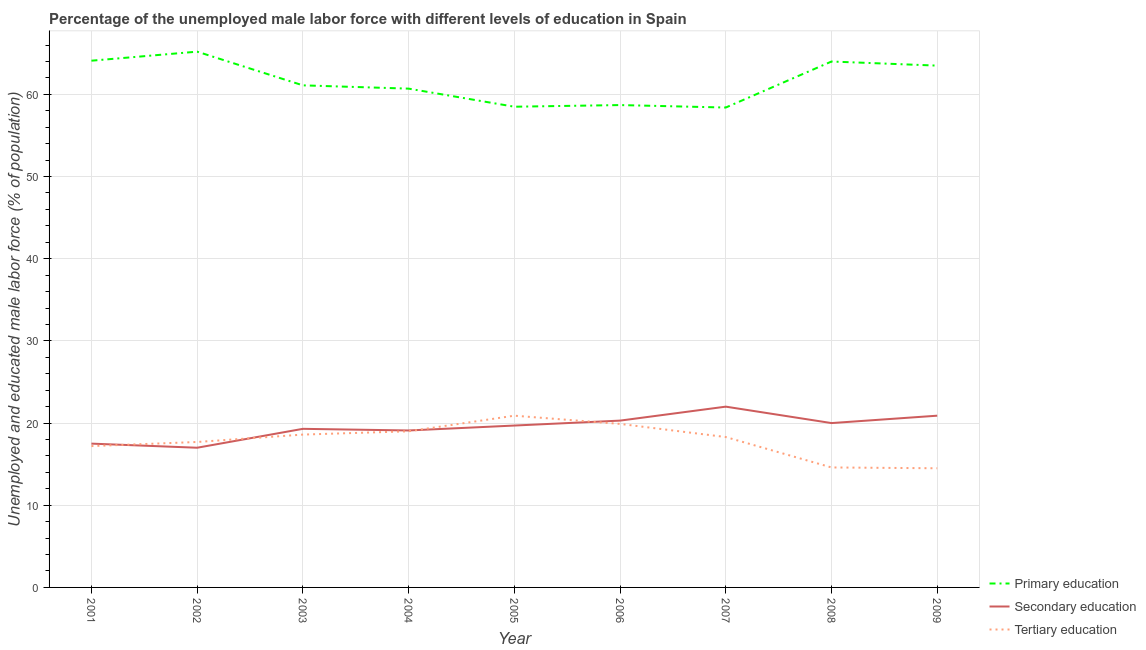Does the line corresponding to percentage of male labor force who received tertiary education intersect with the line corresponding to percentage of male labor force who received secondary education?
Your answer should be very brief. Yes. Is the number of lines equal to the number of legend labels?
Your response must be concise. Yes. What is the percentage of male labor force who received primary education in 2009?
Your answer should be very brief. 63.5. Across all years, what is the maximum percentage of male labor force who received tertiary education?
Provide a short and direct response. 20.9. Across all years, what is the minimum percentage of male labor force who received tertiary education?
Provide a succinct answer. 14.5. In which year was the percentage of male labor force who received tertiary education minimum?
Your answer should be compact. 2009. What is the total percentage of male labor force who received secondary education in the graph?
Provide a succinct answer. 175.8. What is the difference between the percentage of male labor force who received primary education in 2002 and that in 2008?
Your answer should be very brief. 1.2. What is the difference between the percentage of male labor force who received secondary education in 2005 and the percentage of male labor force who received primary education in 2001?
Keep it short and to the point. -44.4. What is the average percentage of male labor force who received secondary education per year?
Give a very brief answer. 19.53. In the year 2004, what is the difference between the percentage of male labor force who received tertiary education and percentage of male labor force who received secondary education?
Ensure brevity in your answer.  -0.1. What is the ratio of the percentage of male labor force who received tertiary education in 2001 to that in 2005?
Provide a succinct answer. 0.82. Is the difference between the percentage of male labor force who received primary education in 2001 and 2005 greater than the difference between the percentage of male labor force who received secondary education in 2001 and 2005?
Your response must be concise. Yes. What is the difference between the highest and the second highest percentage of male labor force who received secondary education?
Provide a short and direct response. 1.1. What is the difference between the highest and the lowest percentage of male labor force who received primary education?
Keep it short and to the point. 6.8. Is the sum of the percentage of male labor force who received tertiary education in 2006 and 2007 greater than the maximum percentage of male labor force who received primary education across all years?
Your response must be concise. No. Is the percentage of male labor force who received tertiary education strictly less than the percentage of male labor force who received secondary education over the years?
Your answer should be very brief. No. Does the graph contain any zero values?
Make the answer very short. No. Does the graph contain grids?
Your answer should be compact. Yes. What is the title of the graph?
Ensure brevity in your answer.  Percentage of the unemployed male labor force with different levels of education in Spain. Does "Primary" appear as one of the legend labels in the graph?
Make the answer very short. No. What is the label or title of the X-axis?
Your response must be concise. Year. What is the label or title of the Y-axis?
Keep it short and to the point. Unemployed and educated male labor force (% of population). What is the Unemployed and educated male labor force (% of population) in Primary education in 2001?
Your answer should be compact. 64.1. What is the Unemployed and educated male labor force (% of population) in Tertiary education in 2001?
Your response must be concise. 17.2. What is the Unemployed and educated male labor force (% of population) of Primary education in 2002?
Keep it short and to the point. 65.2. What is the Unemployed and educated male labor force (% of population) of Secondary education in 2002?
Your response must be concise. 17. What is the Unemployed and educated male labor force (% of population) of Tertiary education in 2002?
Make the answer very short. 17.7. What is the Unemployed and educated male labor force (% of population) in Primary education in 2003?
Ensure brevity in your answer.  61.1. What is the Unemployed and educated male labor force (% of population) in Secondary education in 2003?
Give a very brief answer. 19.3. What is the Unemployed and educated male labor force (% of population) in Tertiary education in 2003?
Your answer should be compact. 18.6. What is the Unemployed and educated male labor force (% of population) of Primary education in 2004?
Your answer should be compact. 60.7. What is the Unemployed and educated male labor force (% of population) of Secondary education in 2004?
Your response must be concise. 19.1. What is the Unemployed and educated male labor force (% of population) in Tertiary education in 2004?
Your answer should be very brief. 19. What is the Unemployed and educated male labor force (% of population) of Primary education in 2005?
Your answer should be compact. 58.5. What is the Unemployed and educated male labor force (% of population) of Secondary education in 2005?
Keep it short and to the point. 19.7. What is the Unemployed and educated male labor force (% of population) in Tertiary education in 2005?
Your answer should be very brief. 20.9. What is the Unemployed and educated male labor force (% of population) of Primary education in 2006?
Provide a short and direct response. 58.7. What is the Unemployed and educated male labor force (% of population) of Secondary education in 2006?
Offer a very short reply. 20.3. What is the Unemployed and educated male labor force (% of population) in Tertiary education in 2006?
Offer a terse response. 19.9. What is the Unemployed and educated male labor force (% of population) of Primary education in 2007?
Keep it short and to the point. 58.4. What is the Unemployed and educated male labor force (% of population) in Secondary education in 2007?
Provide a short and direct response. 22. What is the Unemployed and educated male labor force (% of population) in Tertiary education in 2007?
Offer a very short reply. 18.3. What is the Unemployed and educated male labor force (% of population) of Primary education in 2008?
Keep it short and to the point. 64. What is the Unemployed and educated male labor force (% of population) in Tertiary education in 2008?
Keep it short and to the point. 14.6. What is the Unemployed and educated male labor force (% of population) in Primary education in 2009?
Keep it short and to the point. 63.5. What is the Unemployed and educated male labor force (% of population) in Secondary education in 2009?
Offer a terse response. 20.9. What is the Unemployed and educated male labor force (% of population) in Tertiary education in 2009?
Provide a succinct answer. 14.5. Across all years, what is the maximum Unemployed and educated male labor force (% of population) in Primary education?
Offer a terse response. 65.2. Across all years, what is the maximum Unemployed and educated male labor force (% of population) of Tertiary education?
Offer a very short reply. 20.9. Across all years, what is the minimum Unemployed and educated male labor force (% of population) in Primary education?
Your answer should be very brief. 58.4. Across all years, what is the minimum Unemployed and educated male labor force (% of population) of Secondary education?
Your response must be concise. 17. What is the total Unemployed and educated male labor force (% of population) of Primary education in the graph?
Offer a very short reply. 554.2. What is the total Unemployed and educated male labor force (% of population) of Secondary education in the graph?
Ensure brevity in your answer.  175.8. What is the total Unemployed and educated male labor force (% of population) in Tertiary education in the graph?
Ensure brevity in your answer.  160.7. What is the difference between the Unemployed and educated male labor force (% of population) of Primary education in 2001 and that in 2003?
Provide a short and direct response. 3. What is the difference between the Unemployed and educated male labor force (% of population) of Tertiary education in 2001 and that in 2003?
Your answer should be compact. -1.4. What is the difference between the Unemployed and educated male labor force (% of population) in Secondary education in 2001 and that in 2004?
Make the answer very short. -1.6. What is the difference between the Unemployed and educated male labor force (% of population) of Tertiary education in 2001 and that in 2004?
Keep it short and to the point. -1.8. What is the difference between the Unemployed and educated male labor force (% of population) of Secondary education in 2001 and that in 2005?
Offer a terse response. -2.2. What is the difference between the Unemployed and educated male labor force (% of population) in Primary education in 2001 and that in 2006?
Offer a very short reply. 5.4. What is the difference between the Unemployed and educated male labor force (% of population) in Tertiary education in 2001 and that in 2006?
Give a very brief answer. -2.7. What is the difference between the Unemployed and educated male labor force (% of population) in Primary education in 2001 and that in 2007?
Make the answer very short. 5.7. What is the difference between the Unemployed and educated male labor force (% of population) of Tertiary education in 2001 and that in 2007?
Your answer should be compact. -1.1. What is the difference between the Unemployed and educated male labor force (% of population) of Primary education in 2001 and that in 2009?
Keep it short and to the point. 0.6. What is the difference between the Unemployed and educated male labor force (% of population) of Primary education in 2002 and that in 2003?
Your answer should be very brief. 4.1. What is the difference between the Unemployed and educated male labor force (% of population) of Secondary education in 2002 and that in 2003?
Keep it short and to the point. -2.3. What is the difference between the Unemployed and educated male labor force (% of population) in Tertiary education in 2002 and that in 2003?
Keep it short and to the point. -0.9. What is the difference between the Unemployed and educated male labor force (% of population) in Primary education in 2002 and that in 2004?
Your answer should be very brief. 4.5. What is the difference between the Unemployed and educated male labor force (% of population) in Secondary education in 2002 and that in 2004?
Keep it short and to the point. -2.1. What is the difference between the Unemployed and educated male labor force (% of population) of Primary education in 2002 and that in 2005?
Make the answer very short. 6.7. What is the difference between the Unemployed and educated male labor force (% of population) in Secondary education in 2002 and that in 2005?
Your answer should be very brief. -2.7. What is the difference between the Unemployed and educated male labor force (% of population) in Primary education in 2002 and that in 2006?
Your answer should be compact. 6.5. What is the difference between the Unemployed and educated male labor force (% of population) in Primary education in 2002 and that in 2007?
Your response must be concise. 6.8. What is the difference between the Unemployed and educated male labor force (% of population) in Tertiary education in 2002 and that in 2007?
Offer a very short reply. -0.6. What is the difference between the Unemployed and educated male labor force (% of population) in Primary education in 2002 and that in 2008?
Your response must be concise. 1.2. What is the difference between the Unemployed and educated male labor force (% of population) in Tertiary education in 2002 and that in 2008?
Make the answer very short. 3.1. What is the difference between the Unemployed and educated male labor force (% of population) in Primary education in 2002 and that in 2009?
Give a very brief answer. 1.7. What is the difference between the Unemployed and educated male labor force (% of population) in Primary education in 2003 and that in 2004?
Offer a very short reply. 0.4. What is the difference between the Unemployed and educated male labor force (% of population) of Secondary education in 2003 and that in 2004?
Your response must be concise. 0.2. What is the difference between the Unemployed and educated male labor force (% of population) in Primary education in 2003 and that in 2006?
Give a very brief answer. 2.4. What is the difference between the Unemployed and educated male labor force (% of population) of Tertiary education in 2003 and that in 2006?
Make the answer very short. -1.3. What is the difference between the Unemployed and educated male labor force (% of population) in Primary education in 2003 and that in 2007?
Offer a terse response. 2.7. What is the difference between the Unemployed and educated male labor force (% of population) in Primary education in 2003 and that in 2008?
Keep it short and to the point. -2.9. What is the difference between the Unemployed and educated male labor force (% of population) of Secondary education in 2003 and that in 2008?
Your answer should be compact. -0.7. What is the difference between the Unemployed and educated male labor force (% of population) in Primary education in 2003 and that in 2009?
Your response must be concise. -2.4. What is the difference between the Unemployed and educated male labor force (% of population) of Secondary education in 2004 and that in 2005?
Ensure brevity in your answer.  -0.6. What is the difference between the Unemployed and educated male labor force (% of population) in Primary education in 2004 and that in 2006?
Offer a very short reply. 2. What is the difference between the Unemployed and educated male labor force (% of population) in Secondary education in 2004 and that in 2007?
Make the answer very short. -2.9. What is the difference between the Unemployed and educated male labor force (% of population) of Primary education in 2004 and that in 2008?
Offer a very short reply. -3.3. What is the difference between the Unemployed and educated male labor force (% of population) of Secondary education in 2004 and that in 2008?
Ensure brevity in your answer.  -0.9. What is the difference between the Unemployed and educated male labor force (% of population) of Tertiary education in 2004 and that in 2008?
Offer a terse response. 4.4. What is the difference between the Unemployed and educated male labor force (% of population) in Secondary education in 2005 and that in 2006?
Keep it short and to the point. -0.6. What is the difference between the Unemployed and educated male labor force (% of population) in Tertiary education in 2005 and that in 2006?
Offer a terse response. 1. What is the difference between the Unemployed and educated male labor force (% of population) in Primary education in 2005 and that in 2008?
Your answer should be compact. -5.5. What is the difference between the Unemployed and educated male labor force (% of population) in Tertiary education in 2005 and that in 2008?
Offer a very short reply. 6.3. What is the difference between the Unemployed and educated male labor force (% of population) in Primary education in 2005 and that in 2009?
Make the answer very short. -5. What is the difference between the Unemployed and educated male labor force (% of population) in Secondary education in 2006 and that in 2008?
Ensure brevity in your answer.  0.3. What is the difference between the Unemployed and educated male labor force (% of population) of Primary education in 2006 and that in 2009?
Offer a terse response. -4.8. What is the difference between the Unemployed and educated male labor force (% of population) in Secondary education in 2006 and that in 2009?
Offer a terse response. -0.6. What is the difference between the Unemployed and educated male labor force (% of population) in Secondary education in 2007 and that in 2008?
Provide a succinct answer. 2. What is the difference between the Unemployed and educated male labor force (% of population) in Secondary education in 2007 and that in 2009?
Keep it short and to the point. 1.1. What is the difference between the Unemployed and educated male labor force (% of population) in Primary education in 2008 and that in 2009?
Provide a succinct answer. 0.5. What is the difference between the Unemployed and educated male labor force (% of population) in Secondary education in 2008 and that in 2009?
Provide a succinct answer. -0.9. What is the difference between the Unemployed and educated male labor force (% of population) of Primary education in 2001 and the Unemployed and educated male labor force (% of population) of Secondary education in 2002?
Offer a terse response. 47.1. What is the difference between the Unemployed and educated male labor force (% of population) of Primary education in 2001 and the Unemployed and educated male labor force (% of population) of Tertiary education in 2002?
Ensure brevity in your answer.  46.4. What is the difference between the Unemployed and educated male labor force (% of population) in Secondary education in 2001 and the Unemployed and educated male labor force (% of population) in Tertiary education in 2002?
Give a very brief answer. -0.2. What is the difference between the Unemployed and educated male labor force (% of population) in Primary education in 2001 and the Unemployed and educated male labor force (% of population) in Secondary education in 2003?
Ensure brevity in your answer.  44.8. What is the difference between the Unemployed and educated male labor force (% of population) in Primary education in 2001 and the Unemployed and educated male labor force (% of population) in Tertiary education in 2003?
Make the answer very short. 45.5. What is the difference between the Unemployed and educated male labor force (% of population) of Primary education in 2001 and the Unemployed and educated male labor force (% of population) of Tertiary education in 2004?
Your response must be concise. 45.1. What is the difference between the Unemployed and educated male labor force (% of population) in Secondary education in 2001 and the Unemployed and educated male labor force (% of population) in Tertiary education in 2004?
Make the answer very short. -1.5. What is the difference between the Unemployed and educated male labor force (% of population) of Primary education in 2001 and the Unemployed and educated male labor force (% of population) of Secondary education in 2005?
Your answer should be very brief. 44.4. What is the difference between the Unemployed and educated male labor force (% of population) of Primary education in 2001 and the Unemployed and educated male labor force (% of population) of Tertiary education in 2005?
Offer a terse response. 43.2. What is the difference between the Unemployed and educated male labor force (% of population) in Primary education in 2001 and the Unemployed and educated male labor force (% of population) in Secondary education in 2006?
Your answer should be compact. 43.8. What is the difference between the Unemployed and educated male labor force (% of population) in Primary education in 2001 and the Unemployed and educated male labor force (% of population) in Tertiary education in 2006?
Offer a very short reply. 44.2. What is the difference between the Unemployed and educated male labor force (% of population) in Primary education in 2001 and the Unemployed and educated male labor force (% of population) in Secondary education in 2007?
Keep it short and to the point. 42.1. What is the difference between the Unemployed and educated male labor force (% of population) of Primary education in 2001 and the Unemployed and educated male labor force (% of population) of Tertiary education in 2007?
Make the answer very short. 45.8. What is the difference between the Unemployed and educated male labor force (% of population) of Primary education in 2001 and the Unemployed and educated male labor force (% of population) of Secondary education in 2008?
Your answer should be very brief. 44.1. What is the difference between the Unemployed and educated male labor force (% of population) in Primary education in 2001 and the Unemployed and educated male labor force (% of population) in Tertiary education in 2008?
Your answer should be very brief. 49.5. What is the difference between the Unemployed and educated male labor force (% of population) of Primary education in 2001 and the Unemployed and educated male labor force (% of population) of Secondary education in 2009?
Your answer should be compact. 43.2. What is the difference between the Unemployed and educated male labor force (% of population) in Primary education in 2001 and the Unemployed and educated male labor force (% of population) in Tertiary education in 2009?
Your answer should be compact. 49.6. What is the difference between the Unemployed and educated male labor force (% of population) in Secondary education in 2001 and the Unemployed and educated male labor force (% of population) in Tertiary education in 2009?
Your response must be concise. 3. What is the difference between the Unemployed and educated male labor force (% of population) of Primary education in 2002 and the Unemployed and educated male labor force (% of population) of Secondary education in 2003?
Your answer should be compact. 45.9. What is the difference between the Unemployed and educated male labor force (% of population) in Primary education in 2002 and the Unemployed and educated male labor force (% of population) in Tertiary education in 2003?
Provide a succinct answer. 46.6. What is the difference between the Unemployed and educated male labor force (% of population) in Secondary education in 2002 and the Unemployed and educated male labor force (% of population) in Tertiary education in 2003?
Provide a short and direct response. -1.6. What is the difference between the Unemployed and educated male labor force (% of population) of Primary education in 2002 and the Unemployed and educated male labor force (% of population) of Secondary education in 2004?
Keep it short and to the point. 46.1. What is the difference between the Unemployed and educated male labor force (% of population) in Primary education in 2002 and the Unemployed and educated male labor force (% of population) in Tertiary education in 2004?
Provide a short and direct response. 46.2. What is the difference between the Unemployed and educated male labor force (% of population) of Secondary education in 2002 and the Unemployed and educated male labor force (% of population) of Tertiary education in 2004?
Provide a short and direct response. -2. What is the difference between the Unemployed and educated male labor force (% of population) in Primary education in 2002 and the Unemployed and educated male labor force (% of population) in Secondary education in 2005?
Provide a short and direct response. 45.5. What is the difference between the Unemployed and educated male labor force (% of population) of Primary education in 2002 and the Unemployed and educated male labor force (% of population) of Tertiary education in 2005?
Keep it short and to the point. 44.3. What is the difference between the Unemployed and educated male labor force (% of population) in Primary education in 2002 and the Unemployed and educated male labor force (% of population) in Secondary education in 2006?
Provide a succinct answer. 44.9. What is the difference between the Unemployed and educated male labor force (% of population) of Primary education in 2002 and the Unemployed and educated male labor force (% of population) of Tertiary education in 2006?
Your answer should be compact. 45.3. What is the difference between the Unemployed and educated male labor force (% of population) of Primary education in 2002 and the Unemployed and educated male labor force (% of population) of Secondary education in 2007?
Give a very brief answer. 43.2. What is the difference between the Unemployed and educated male labor force (% of population) in Primary education in 2002 and the Unemployed and educated male labor force (% of population) in Tertiary education in 2007?
Your response must be concise. 46.9. What is the difference between the Unemployed and educated male labor force (% of population) in Secondary education in 2002 and the Unemployed and educated male labor force (% of population) in Tertiary education in 2007?
Provide a succinct answer. -1.3. What is the difference between the Unemployed and educated male labor force (% of population) of Primary education in 2002 and the Unemployed and educated male labor force (% of population) of Secondary education in 2008?
Offer a very short reply. 45.2. What is the difference between the Unemployed and educated male labor force (% of population) in Primary education in 2002 and the Unemployed and educated male labor force (% of population) in Tertiary education in 2008?
Your answer should be compact. 50.6. What is the difference between the Unemployed and educated male labor force (% of population) in Secondary education in 2002 and the Unemployed and educated male labor force (% of population) in Tertiary education in 2008?
Keep it short and to the point. 2.4. What is the difference between the Unemployed and educated male labor force (% of population) of Primary education in 2002 and the Unemployed and educated male labor force (% of population) of Secondary education in 2009?
Your answer should be very brief. 44.3. What is the difference between the Unemployed and educated male labor force (% of population) in Primary education in 2002 and the Unemployed and educated male labor force (% of population) in Tertiary education in 2009?
Your response must be concise. 50.7. What is the difference between the Unemployed and educated male labor force (% of population) of Primary education in 2003 and the Unemployed and educated male labor force (% of population) of Secondary education in 2004?
Provide a succinct answer. 42. What is the difference between the Unemployed and educated male labor force (% of population) of Primary education in 2003 and the Unemployed and educated male labor force (% of population) of Tertiary education in 2004?
Your response must be concise. 42.1. What is the difference between the Unemployed and educated male labor force (% of population) in Secondary education in 2003 and the Unemployed and educated male labor force (% of population) in Tertiary education in 2004?
Your answer should be very brief. 0.3. What is the difference between the Unemployed and educated male labor force (% of population) in Primary education in 2003 and the Unemployed and educated male labor force (% of population) in Secondary education in 2005?
Provide a succinct answer. 41.4. What is the difference between the Unemployed and educated male labor force (% of population) of Primary education in 2003 and the Unemployed and educated male labor force (% of population) of Tertiary education in 2005?
Your response must be concise. 40.2. What is the difference between the Unemployed and educated male labor force (% of population) in Secondary education in 2003 and the Unemployed and educated male labor force (% of population) in Tertiary education in 2005?
Keep it short and to the point. -1.6. What is the difference between the Unemployed and educated male labor force (% of population) in Primary education in 2003 and the Unemployed and educated male labor force (% of population) in Secondary education in 2006?
Your answer should be compact. 40.8. What is the difference between the Unemployed and educated male labor force (% of population) in Primary education in 2003 and the Unemployed and educated male labor force (% of population) in Tertiary education in 2006?
Provide a succinct answer. 41.2. What is the difference between the Unemployed and educated male labor force (% of population) of Secondary education in 2003 and the Unemployed and educated male labor force (% of population) of Tertiary education in 2006?
Make the answer very short. -0.6. What is the difference between the Unemployed and educated male labor force (% of population) of Primary education in 2003 and the Unemployed and educated male labor force (% of population) of Secondary education in 2007?
Provide a short and direct response. 39.1. What is the difference between the Unemployed and educated male labor force (% of population) in Primary education in 2003 and the Unemployed and educated male labor force (% of population) in Tertiary education in 2007?
Offer a terse response. 42.8. What is the difference between the Unemployed and educated male labor force (% of population) of Primary education in 2003 and the Unemployed and educated male labor force (% of population) of Secondary education in 2008?
Ensure brevity in your answer.  41.1. What is the difference between the Unemployed and educated male labor force (% of population) of Primary education in 2003 and the Unemployed and educated male labor force (% of population) of Tertiary education in 2008?
Provide a short and direct response. 46.5. What is the difference between the Unemployed and educated male labor force (% of population) in Secondary education in 2003 and the Unemployed and educated male labor force (% of population) in Tertiary education in 2008?
Keep it short and to the point. 4.7. What is the difference between the Unemployed and educated male labor force (% of population) in Primary education in 2003 and the Unemployed and educated male labor force (% of population) in Secondary education in 2009?
Your response must be concise. 40.2. What is the difference between the Unemployed and educated male labor force (% of population) of Primary education in 2003 and the Unemployed and educated male labor force (% of population) of Tertiary education in 2009?
Give a very brief answer. 46.6. What is the difference between the Unemployed and educated male labor force (% of population) in Primary education in 2004 and the Unemployed and educated male labor force (% of population) in Tertiary education in 2005?
Provide a short and direct response. 39.8. What is the difference between the Unemployed and educated male labor force (% of population) in Primary education in 2004 and the Unemployed and educated male labor force (% of population) in Secondary education in 2006?
Offer a very short reply. 40.4. What is the difference between the Unemployed and educated male labor force (% of population) in Primary education in 2004 and the Unemployed and educated male labor force (% of population) in Tertiary education in 2006?
Offer a terse response. 40.8. What is the difference between the Unemployed and educated male labor force (% of population) in Secondary education in 2004 and the Unemployed and educated male labor force (% of population) in Tertiary education in 2006?
Ensure brevity in your answer.  -0.8. What is the difference between the Unemployed and educated male labor force (% of population) in Primary education in 2004 and the Unemployed and educated male labor force (% of population) in Secondary education in 2007?
Your answer should be compact. 38.7. What is the difference between the Unemployed and educated male labor force (% of population) of Primary education in 2004 and the Unemployed and educated male labor force (% of population) of Tertiary education in 2007?
Provide a succinct answer. 42.4. What is the difference between the Unemployed and educated male labor force (% of population) of Primary education in 2004 and the Unemployed and educated male labor force (% of population) of Secondary education in 2008?
Your answer should be compact. 40.7. What is the difference between the Unemployed and educated male labor force (% of population) in Primary education in 2004 and the Unemployed and educated male labor force (% of population) in Tertiary education in 2008?
Your response must be concise. 46.1. What is the difference between the Unemployed and educated male labor force (% of population) of Primary education in 2004 and the Unemployed and educated male labor force (% of population) of Secondary education in 2009?
Give a very brief answer. 39.8. What is the difference between the Unemployed and educated male labor force (% of population) in Primary education in 2004 and the Unemployed and educated male labor force (% of population) in Tertiary education in 2009?
Ensure brevity in your answer.  46.2. What is the difference between the Unemployed and educated male labor force (% of population) of Primary education in 2005 and the Unemployed and educated male labor force (% of population) of Secondary education in 2006?
Provide a short and direct response. 38.2. What is the difference between the Unemployed and educated male labor force (% of population) in Primary education in 2005 and the Unemployed and educated male labor force (% of population) in Tertiary education in 2006?
Your answer should be very brief. 38.6. What is the difference between the Unemployed and educated male labor force (% of population) of Secondary education in 2005 and the Unemployed and educated male labor force (% of population) of Tertiary education in 2006?
Offer a very short reply. -0.2. What is the difference between the Unemployed and educated male labor force (% of population) in Primary education in 2005 and the Unemployed and educated male labor force (% of population) in Secondary education in 2007?
Provide a succinct answer. 36.5. What is the difference between the Unemployed and educated male labor force (% of population) of Primary education in 2005 and the Unemployed and educated male labor force (% of population) of Tertiary education in 2007?
Your response must be concise. 40.2. What is the difference between the Unemployed and educated male labor force (% of population) of Primary education in 2005 and the Unemployed and educated male labor force (% of population) of Secondary education in 2008?
Your response must be concise. 38.5. What is the difference between the Unemployed and educated male labor force (% of population) in Primary education in 2005 and the Unemployed and educated male labor force (% of population) in Tertiary education in 2008?
Offer a terse response. 43.9. What is the difference between the Unemployed and educated male labor force (% of population) in Primary education in 2005 and the Unemployed and educated male labor force (% of population) in Secondary education in 2009?
Offer a terse response. 37.6. What is the difference between the Unemployed and educated male labor force (% of population) in Primary education in 2005 and the Unemployed and educated male labor force (% of population) in Tertiary education in 2009?
Keep it short and to the point. 44. What is the difference between the Unemployed and educated male labor force (% of population) of Secondary education in 2005 and the Unemployed and educated male labor force (% of population) of Tertiary education in 2009?
Your response must be concise. 5.2. What is the difference between the Unemployed and educated male labor force (% of population) in Primary education in 2006 and the Unemployed and educated male labor force (% of population) in Secondary education in 2007?
Give a very brief answer. 36.7. What is the difference between the Unemployed and educated male labor force (% of population) of Primary education in 2006 and the Unemployed and educated male labor force (% of population) of Tertiary education in 2007?
Your response must be concise. 40.4. What is the difference between the Unemployed and educated male labor force (% of population) of Primary education in 2006 and the Unemployed and educated male labor force (% of population) of Secondary education in 2008?
Offer a terse response. 38.7. What is the difference between the Unemployed and educated male labor force (% of population) in Primary education in 2006 and the Unemployed and educated male labor force (% of population) in Tertiary education in 2008?
Provide a short and direct response. 44.1. What is the difference between the Unemployed and educated male labor force (% of population) of Secondary education in 2006 and the Unemployed and educated male labor force (% of population) of Tertiary education in 2008?
Your response must be concise. 5.7. What is the difference between the Unemployed and educated male labor force (% of population) in Primary education in 2006 and the Unemployed and educated male labor force (% of population) in Secondary education in 2009?
Keep it short and to the point. 37.8. What is the difference between the Unemployed and educated male labor force (% of population) in Primary education in 2006 and the Unemployed and educated male labor force (% of population) in Tertiary education in 2009?
Offer a terse response. 44.2. What is the difference between the Unemployed and educated male labor force (% of population) in Secondary education in 2006 and the Unemployed and educated male labor force (% of population) in Tertiary education in 2009?
Your response must be concise. 5.8. What is the difference between the Unemployed and educated male labor force (% of population) in Primary education in 2007 and the Unemployed and educated male labor force (% of population) in Secondary education in 2008?
Your answer should be compact. 38.4. What is the difference between the Unemployed and educated male labor force (% of population) in Primary education in 2007 and the Unemployed and educated male labor force (% of population) in Tertiary education in 2008?
Provide a short and direct response. 43.8. What is the difference between the Unemployed and educated male labor force (% of population) in Secondary education in 2007 and the Unemployed and educated male labor force (% of population) in Tertiary education in 2008?
Your answer should be very brief. 7.4. What is the difference between the Unemployed and educated male labor force (% of population) in Primary education in 2007 and the Unemployed and educated male labor force (% of population) in Secondary education in 2009?
Keep it short and to the point. 37.5. What is the difference between the Unemployed and educated male labor force (% of population) in Primary education in 2007 and the Unemployed and educated male labor force (% of population) in Tertiary education in 2009?
Your response must be concise. 43.9. What is the difference between the Unemployed and educated male labor force (% of population) in Primary education in 2008 and the Unemployed and educated male labor force (% of population) in Secondary education in 2009?
Offer a terse response. 43.1. What is the difference between the Unemployed and educated male labor force (% of population) in Primary education in 2008 and the Unemployed and educated male labor force (% of population) in Tertiary education in 2009?
Your answer should be compact. 49.5. What is the difference between the Unemployed and educated male labor force (% of population) of Secondary education in 2008 and the Unemployed and educated male labor force (% of population) of Tertiary education in 2009?
Provide a short and direct response. 5.5. What is the average Unemployed and educated male labor force (% of population) of Primary education per year?
Offer a very short reply. 61.58. What is the average Unemployed and educated male labor force (% of population) in Secondary education per year?
Your answer should be compact. 19.53. What is the average Unemployed and educated male labor force (% of population) of Tertiary education per year?
Offer a very short reply. 17.86. In the year 2001, what is the difference between the Unemployed and educated male labor force (% of population) in Primary education and Unemployed and educated male labor force (% of population) in Secondary education?
Your answer should be compact. 46.6. In the year 2001, what is the difference between the Unemployed and educated male labor force (% of population) in Primary education and Unemployed and educated male labor force (% of population) in Tertiary education?
Your response must be concise. 46.9. In the year 2002, what is the difference between the Unemployed and educated male labor force (% of population) of Primary education and Unemployed and educated male labor force (% of population) of Secondary education?
Your answer should be very brief. 48.2. In the year 2002, what is the difference between the Unemployed and educated male labor force (% of population) of Primary education and Unemployed and educated male labor force (% of population) of Tertiary education?
Provide a succinct answer. 47.5. In the year 2002, what is the difference between the Unemployed and educated male labor force (% of population) of Secondary education and Unemployed and educated male labor force (% of population) of Tertiary education?
Provide a short and direct response. -0.7. In the year 2003, what is the difference between the Unemployed and educated male labor force (% of population) of Primary education and Unemployed and educated male labor force (% of population) of Secondary education?
Provide a short and direct response. 41.8. In the year 2003, what is the difference between the Unemployed and educated male labor force (% of population) of Primary education and Unemployed and educated male labor force (% of population) of Tertiary education?
Provide a short and direct response. 42.5. In the year 2003, what is the difference between the Unemployed and educated male labor force (% of population) in Secondary education and Unemployed and educated male labor force (% of population) in Tertiary education?
Offer a terse response. 0.7. In the year 2004, what is the difference between the Unemployed and educated male labor force (% of population) in Primary education and Unemployed and educated male labor force (% of population) in Secondary education?
Your answer should be very brief. 41.6. In the year 2004, what is the difference between the Unemployed and educated male labor force (% of population) of Primary education and Unemployed and educated male labor force (% of population) of Tertiary education?
Make the answer very short. 41.7. In the year 2004, what is the difference between the Unemployed and educated male labor force (% of population) in Secondary education and Unemployed and educated male labor force (% of population) in Tertiary education?
Give a very brief answer. 0.1. In the year 2005, what is the difference between the Unemployed and educated male labor force (% of population) of Primary education and Unemployed and educated male labor force (% of population) of Secondary education?
Offer a very short reply. 38.8. In the year 2005, what is the difference between the Unemployed and educated male labor force (% of population) of Primary education and Unemployed and educated male labor force (% of population) of Tertiary education?
Ensure brevity in your answer.  37.6. In the year 2006, what is the difference between the Unemployed and educated male labor force (% of population) of Primary education and Unemployed and educated male labor force (% of population) of Secondary education?
Ensure brevity in your answer.  38.4. In the year 2006, what is the difference between the Unemployed and educated male labor force (% of population) of Primary education and Unemployed and educated male labor force (% of population) of Tertiary education?
Your response must be concise. 38.8. In the year 2006, what is the difference between the Unemployed and educated male labor force (% of population) in Secondary education and Unemployed and educated male labor force (% of population) in Tertiary education?
Provide a succinct answer. 0.4. In the year 2007, what is the difference between the Unemployed and educated male labor force (% of population) of Primary education and Unemployed and educated male labor force (% of population) of Secondary education?
Keep it short and to the point. 36.4. In the year 2007, what is the difference between the Unemployed and educated male labor force (% of population) of Primary education and Unemployed and educated male labor force (% of population) of Tertiary education?
Keep it short and to the point. 40.1. In the year 2008, what is the difference between the Unemployed and educated male labor force (% of population) of Primary education and Unemployed and educated male labor force (% of population) of Tertiary education?
Ensure brevity in your answer.  49.4. In the year 2009, what is the difference between the Unemployed and educated male labor force (% of population) in Primary education and Unemployed and educated male labor force (% of population) in Secondary education?
Provide a succinct answer. 42.6. In the year 2009, what is the difference between the Unemployed and educated male labor force (% of population) of Primary education and Unemployed and educated male labor force (% of population) of Tertiary education?
Offer a terse response. 49. In the year 2009, what is the difference between the Unemployed and educated male labor force (% of population) in Secondary education and Unemployed and educated male labor force (% of population) in Tertiary education?
Your answer should be compact. 6.4. What is the ratio of the Unemployed and educated male labor force (% of population) of Primary education in 2001 to that in 2002?
Provide a succinct answer. 0.98. What is the ratio of the Unemployed and educated male labor force (% of population) of Secondary education in 2001 to that in 2002?
Offer a terse response. 1.03. What is the ratio of the Unemployed and educated male labor force (% of population) in Tertiary education in 2001 to that in 2002?
Provide a short and direct response. 0.97. What is the ratio of the Unemployed and educated male labor force (% of population) in Primary education in 2001 to that in 2003?
Ensure brevity in your answer.  1.05. What is the ratio of the Unemployed and educated male labor force (% of population) in Secondary education in 2001 to that in 2003?
Your response must be concise. 0.91. What is the ratio of the Unemployed and educated male labor force (% of population) of Tertiary education in 2001 to that in 2003?
Ensure brevity in your answer.  0.92. What is the ratio of the Unemployed and educated male labor force (% of population) in Primary education in 2001 to that in 2004?
Provide a succinct answer. 1.06. What is the ratio of the Unemployed and educated male labor force (% of population) of Secondary education in 2001 to that in 2004?
Your answer should be compact. 0.92. What is the ratio of the Unemployed and educated male labor force (% of population) in Tertiary education in 2001 to that in 2004?
Provide a succinct answer. 0.91. What is the ratio of the Unemployed and educated male labor force (% of population) of Primary education in 2001 to that in 2005?
Your answer should be very brief. 1.1. What is the ratio of the Unemployed and educated male labor force (% of population) in Secondary education in 2001 to that in 2005?
Make the answer very short. 0.89. What is the ratio of the Unemployed and educated male labor force (% of population) in Tertiary education in 2001 to that in 2005?
Make the answer very short. 0.82. What is the ratio of the Unemployed and educated male labor force (% of population) of Primary education in 2001 to that in 2006?
Your response must be concise. 1.09. What is the ratio of the Unemployed and educated male labor force (% of population) of Secondary education in 2001 to that in 2006?
Provide a short and direct response. 0.86. What is the ratio of the Unemployed and educated male labor force (% of population) of Tertiary education in 2001 to that in 2006?
Offer a terse response. 0.86. What is the ratio of the Unemployed and educated male labor force (% of population) of Primary education in 2001 to that in 2007?
Ensure brevity in your answer.  1.1. What is the ratio of the Unemployed and educated male labor force (% of population) in Secondary education in 2001 to that in 2007?
Provide a succinct answer. 0.8. What is the ratio of the Unemployed and educated male labor force (% of population) of Tertiary education in 2001 to that in 2007?
Offer a very short reply. 0.94. What is the ratio of the Unemployed and educated male labor force (% of population) of Primary education in 2001 to that in 2008?
Ensure brevity in your answer.  1. What is the ratio of the Unemployed and educated male labor force (% of population) of Secondary education in 2001 to that in 2008?
Make the answer very short. 0.88. What is the ratio of the Unemployed and educated male labor force (% of population) of Tertiary education in 2001 to that in 2008?
Your answer should be compact. 1.18. What is the ratio of the Unemployed and educated male labor force (% of population) of Primary education in 2001 to that in 2009?
Make the answer very short. 1.01. What is the ratio of the Unemployed and educated male labor force (% of population) in Secondary education in 2001 to that in 2009?
Ensure brevity in your answer.  0.84. What is the ratio of the Unemployed and educated male labor force (% of population) of Tertiary education in 2001 to that in 2009?
Keep it short and to the point. 1.19. What is the ratio of the Unemployed and educated male labor force (% of population) in Primary education in 2002 to that in 2003?
Your response must be concise. 1.07. What is the ratio of the Unemployed and educated male labor force (% of population) of Secondary education in 2002 to that in 2003?
Your response must be concise. 0.88. What is the ratio of the Unemployed and educated male labor force (% of population) in Tertiary education in 2002 to that in 2003?
Provide a succinct answer. 0.95. What is the ratio of the Unemployed and educated male labor force (% of population) in Primary education in 2002 to that in 2004?
Your response must be concise. 1.07. What is the ratio of the Unemployed and educated male labor force (% of population) of Secondary education in 2002 to that in 2004?
Provide a succinct answer. 0.89. What is the ratio of the Unemployed and educated male labor force (% of population) of Tertiary education in 2002 to that in 2004?
Give a very brief answer. 0.93. What is the ratio of the Unemployed and educated male labor force (% of population) of Primary education in 2002 to that in 2005?
Give a very brief answer. 1.11. What is the ratio of the Unemployed and educated male labor force (% of population) in Secondary education in 2002 to that in 2005?
Ensure brevity in your answer.  0.86. What is the ratio of the Unemployed and educated male labor force (% of population) in Tertiary education in 2002 to that in 2005?
Your answer should be very brief. 0.85. What is the ratio of the Unemployed and educated male labor force (% of population) in Primary education in 2002 to that in 2006?
Your answer should be compact. 1.11. What is the ratio of the Unemployed and educated male labor force (% of population) in Secondary education in 2002 to that in 2006?
Offer a terse response. 0.84. What is the ratio of the Unemployed and educated male labor force (% of population) of Tertiary education in 2002 to that in 2006?
Give a very brief answer. 0.89. What is the ratio of the Unemployed and educated male labor force (% of population) in Primary education in 2002 to that in 2007?
Ensure brevity in your answer.  1.12. What is the ratio of the Unemployed and educated male labor force (% of population) in Secondary education in 2002 to that in 2007?
Make the answer very short. 0.77. What is the ratio of the Unemployed and educated male labor force (% of population) of Tertiary education in 2002 to that in 2007?
Your answer should be compact. 0.97. What is the ratio of the Unemployed and educated male labor force (% of population) of Primary education in 2002 to that in 2008?
Offer a very short reply. 1.02. What is the ratio of the Unemployed and educated male labor force (% of population) of Tertiary education in 2002 to that in 2008?
Ensure brevity in your answer.  1.21. What is the ratio of the Unemployed and educated male labor force (% of population) of Primary education in 2002 to that in 2009?
Offer a very short reply. 1.03. What is the ratio of the Unemployed and educated male labor force (% of population) in Secondary education in 2002 to that in 2009?
Your response must be concise. 0.81. What is the ratio of the Unemployed and educated male labor force (% of population) in Tertiary education in 2002 to that in 2009?
Keep it short and to the point. 1.22. What is the ratio of the Unemployed and educated male labor force (% of population) in Primary education in 2003 to that in 2004?
Ensure brevity in your answer.  1.01. What is the ratio of the Unemployed and educated male labor force (% of population) of Secondary education in 2003 to that in 2004?
Offer a very short reply. 1.01. What is the ratio of the Unemployed and educated male labor force (% of population) in Tertiary education in 2003 to that in 2004?
Make the answer very short. 0.98. What is the ratio of the Unemployed and educated male labor force (% of population) in Primary education in 2003 to that in 2005?
Provide a short and direct response. 1.04. What is the ratio of the Unemployed and educated male labor force (% of population) in Secondary education in 2003 to that in 2005?
Ensure brevity in your answer.  0.98. What is the ratio of the Unemployed and educated male labor force (% of population) of Tertiary education in 2003 to that in 2005?
Provide a short and direct response. 0.89. What is the ratio of the Unemployed and educated male labor force (% of population) in Primary education in 2003 to that in 2006?
Offer a terse response. 1.04. What is the ratio of the Unemployed and educated male labor force (% of population) of Secondary education in 2003 to that in 2006?
Offer a very short reply. 0.95. What is the ratio of the Unemployed and educated male labor force (% of population) of Tertiary education in 2003 to that in 2006?
Your response must be concise. 0.93. What is the ratio of the Unemployed and educated male labor force (% of population) of Primary education in 2003 to that in 2007?
Make the answer very short. 1.05. What is the ratio of the Unemployed and educated male labor force (% of population) of Secondary education in 2003 to that in 2007?
Ensure brevity in your answer.  0.88. What is the ratio of the Unemployed and educated male labor force (% of population) in Tertiary education in 2003 to that in 2007?
Offer a terse response. 1.02. What is the ratio of the Unemployed and educated male labor force (% of population) of Primary education in 2003 to that in 2008?
Your answer should be compact. 0.95. What is the ratio of the Unemployed and educated male labor force (% of population) in Secondary education in 2003 to that in 2008?
Keep it short and to the point. 0.96. What is the ratio of the Unemployed and educated male labor force (% of population) of Tertiary education in 2003 to that in 2008?
Your response must be concise. 1.27. What is the ratio of the Unemployed and educated male labor force (% of population) of Primary education in 2003 to that in 2009?
Provide a succinct answer. 0.96. What is the ratio of the Unemployed and educated male labor force (% of population) in Secondary education in 2003 to that in 2009?
Offer a very short reply. 0.92. What is the ratio of the Unemployed and educated male labor force (% of population) in Tertiary education in 2003 to that in 2009?
Your answer should be compact. 1.28. What is the ratio of the Unemployed and educated male labor force (% of population) of Primary education in 2004 to that in 2005?
Offer a terse response. 1.04. What is the ratio of the Unemployed and educated male labor force (% of population) in Secondary education in 2004 to that in 2005?
Give a very brief answer. 0.97. What is the ratio of the Unemployed and educated male labor force (% of population) of Tertiary education in 2004 to that in 2005?
Give a very brief answer. 0.91. What is the ratio of the Unemployed and educated male labor force (% of population) in Primary education in 2004 to that in 2006?
Offer a very short reply. 1.03. What is the ratio of the Unemployed and educated male labor force (% of population) in Secondary education in 2004 to that in 2006?
Your answer should be compact. 0.94. What is the ratio of the Unemployed and educated male labor force (% of population) in Tertiary education in 2004 to that in 2006?
Provide a short and direct response. 0.95. What is the ratio of the Unemployed and educated male labor force (% of population) of Primary education in 2004 to that in 2007?
Provide a succinct answer. 1.04. What is the ratio of the Unemployed and educated male labor force (% of population) in Secondary education in 2004 to that in 2007?
Keep it short and to the point. 0.87. What is the ratio of the Unemployed and educated male labor force (% of population) of Tertiary education in 2004 to that in 2007?
Ensure brevity in your answer.  1.04. What is the ratio of the Unemployed and educated male labor force (% of population) of Primary education in 2004 to that in 2008?
Provide a short and direct response. 0.95. What is the ratio of the Unemployed and educated male labor force (% of population) in Secondary education in 2004 to that in 2008?
Your response must be concise. 0.95. What is the ratio of the Unemployed and educated male labor force (% of population) in Tertiary education in 2004 to that in 2008?
Offer a terse response. 1.3. What is the ratio of the Unemployed and educated male labor force (% of population) in Primary education in 2004 to that in 2009?
Give a very brief answer. 0.96. What is the ratio of the Unemployed and educated male labor force (% of population) of Secondary education in 2004 to that in 2009?
Keep it short and to the point. 0.91. What is the ratio of the Unemployed and educated male labor force (% of population) in Tertiary education in 2004 to that in 2009?
Make the answer very short. 1.31. What is the ratio of the Unemployed and educated male labor force (% of population) of Primary education in 2005 to that in 2006?
Offer a terse response. 1. What is the ratio of the Unemployed and educated male labor force (% of population) of Secondary education in 2005 to that in 2006?
Keep it short and to the point. 0.97. What is the ratio of the Unemployed and educated male labor force (% of population) of Tertiary education in 2005 to that in 2006?
Provide a short and direct response. 1.05. What is the ratio of the Unemployed and educated male labor force (% of population) in Primary education in 2005 to that in 2007?
Keep it short and to the point. 1. What is the ratio of the Unemployed and educated male labor force (% of population) in Secondary education in 2005 to that in 2007?
Give a very brief answer. 0.9. What is the ratio of the Unemployed and educated male labor force (% of population) in Tertiary education in 2005 to that in 2007?
Your answer should be very brief. 1.14. What is the ratio of the Unemployed and educated male labor force (% of population) in Primary education in 2005 to that in 2008?
Your response must be concise. 0.91. What is the ratio of the Unemployed and educated male labor force (% of population) in Secondary education in 2005 to that in 2008?
Provide a succinct answer. 0.98. What is the ratio of the Unemployed and educated male labor force (% of population) in Tertiary education in 2005 to that in 2008?
Provide a succinct answer. 1.43. What is the ratio of the Unemployed and educated male labor force (% of population) of Primary education in 2005 to that in 2009?
Offer a terse response. 0.92. What is the ratio of the Unemployed and educated male labor force (% of population) of Secondary education in 2005 to that in 2009?
Offer a very short reply. 0.94. What is the ratio of the Unemployed and educated male labor force (% of population) of Tertiary education in 2005 to that in 2009?
Provide a short and direct response. 1.44. What is the ratio of the Unemployed and educated male labor force (% of population) of Secondary education in 2006 to that in 2007?
Your answer should be very brief. 0.92. What is the ratio of the Unemployed and educated male labor force (% of population) in Tertiary education in 2006 to that in 2007?
Ensure brevity in your answer.  1.09. What is the ratio of the Unemployed and educated male labor force (% of population) in Primary education in 2006 to that in 2008?
Your answer should be very brief. 0.92. What is the ratio of the Unemployed and educated male labor force (% of population) of Tertiary education in 2006 to that in 2008?
Your response must be concise. 1.36. What is the ratio of the Unemployed and educated male labor force (% of population) of Primary education in 2006 to that in 2009?
Ensure brevity in your answer.  0.92. What is the ratio of the Unemployed and educated male labor force (% of population) in Secondary education in 2006 to that in 2009?
Your answer should be compact. 0.97. What is the ratio of the Unemployed and educated male labor force (% of population) in Tertiary education in 2006 to that in 2009?
Your answer should be very brief. 1.37. What is the ratio of the Unemployed and educated male labor force (% of population) of Primary education in 2007 to that in 2008?
Your answer should be very brief. 0.91. What is the ratio of the Unemployed and educated male labor force (% of population) in Secondary education in 2007 to that in 2008?
Offer a very short reply. 1.1. What is the ratio of the Unemployed and educated male labor force (% of population) in Tertiary education in 2007 to that in 2008?
Offer a terse response. 1.25. What is the ratio of the Unemployed and educated male labor force (% of population) of Primary education in 2007 to that in 2009?
Give a very brief answer. 0.92. What is the ratio of the Unemployed and educated male labor force (% of population) in Secondary education in 2007 to that in 2009?
Offer a terse response. 1.05. What is the ratio of the Unemployed and educated male labor force (% of population) of Tertiary education in 2007 to that in 2009?
Your answer should be compact. 1.26. What is the ratio of the Unemployed and educated male labor force (% of population) of Primary education in 2008 to that in 2009?
Your response must be concise. 1.01. What is the ratio of the Unemployed and educated male labor force (% of population) in Secondary education in 2008 to that in 2009?
Keep it short and to the point. 0.96. What is the difference between the highest and the lowest Unemployed and educated male labor force (% of population) of Secondary education?
Ensure brevity in your answer.  5. What is the difference between the highest and the lowest Unemployed and educated male labor force (% of population) of Tertiary education?
Provide a short and direct response. 6.4. 